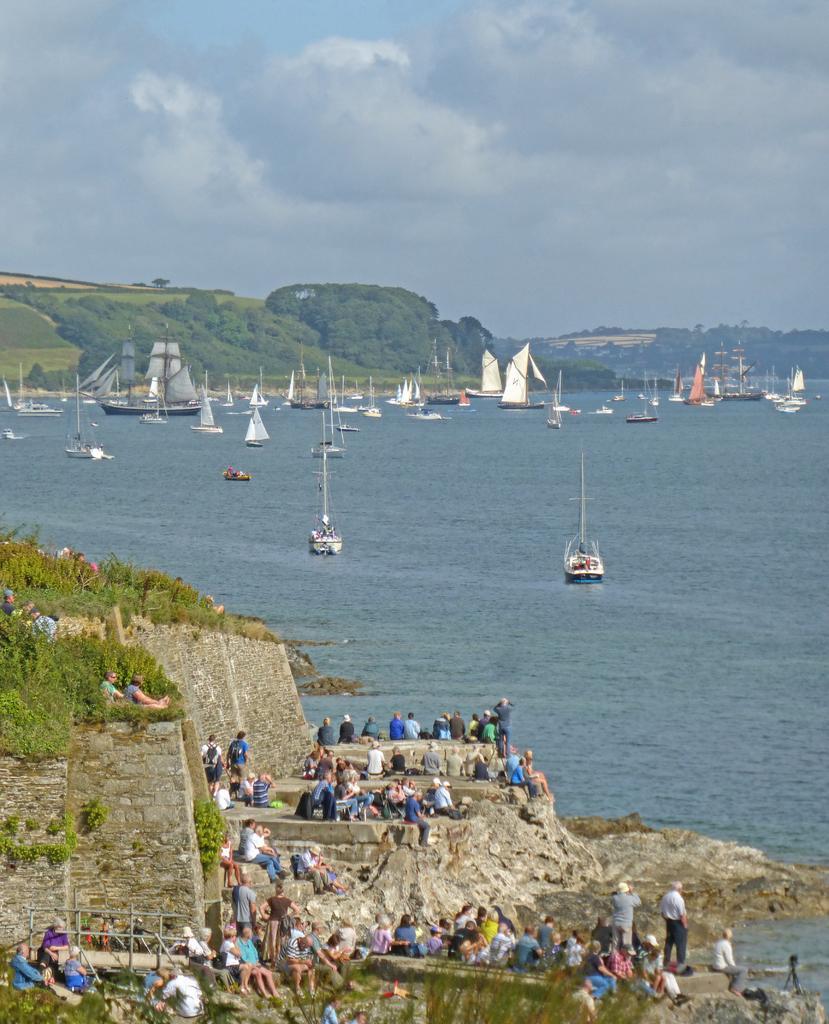How would you summarize this image in a sentence or two? There is a group of persons present at the bottom of this image. We can see some plants on the left side of this image. There are boats on the surface of water in the middle of this image and there are trees and mountains in the background. We can see a cloudy sky at the top of this image. 